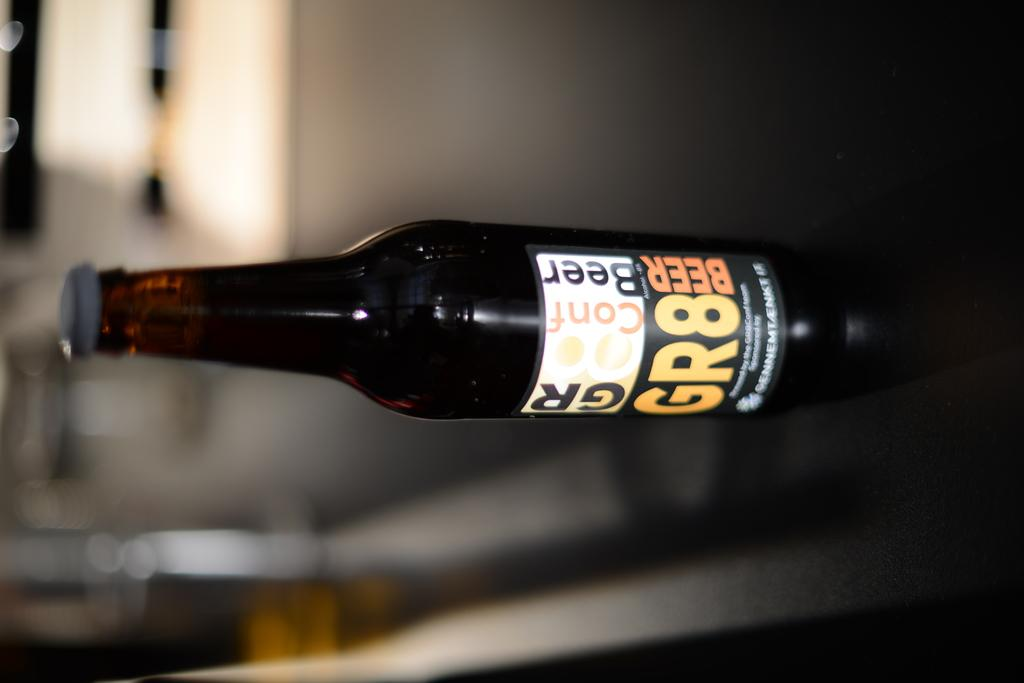<image>
Give a short and clear explanation of the subsequent image. A bottle of beer is labeled with the brand GR8. 